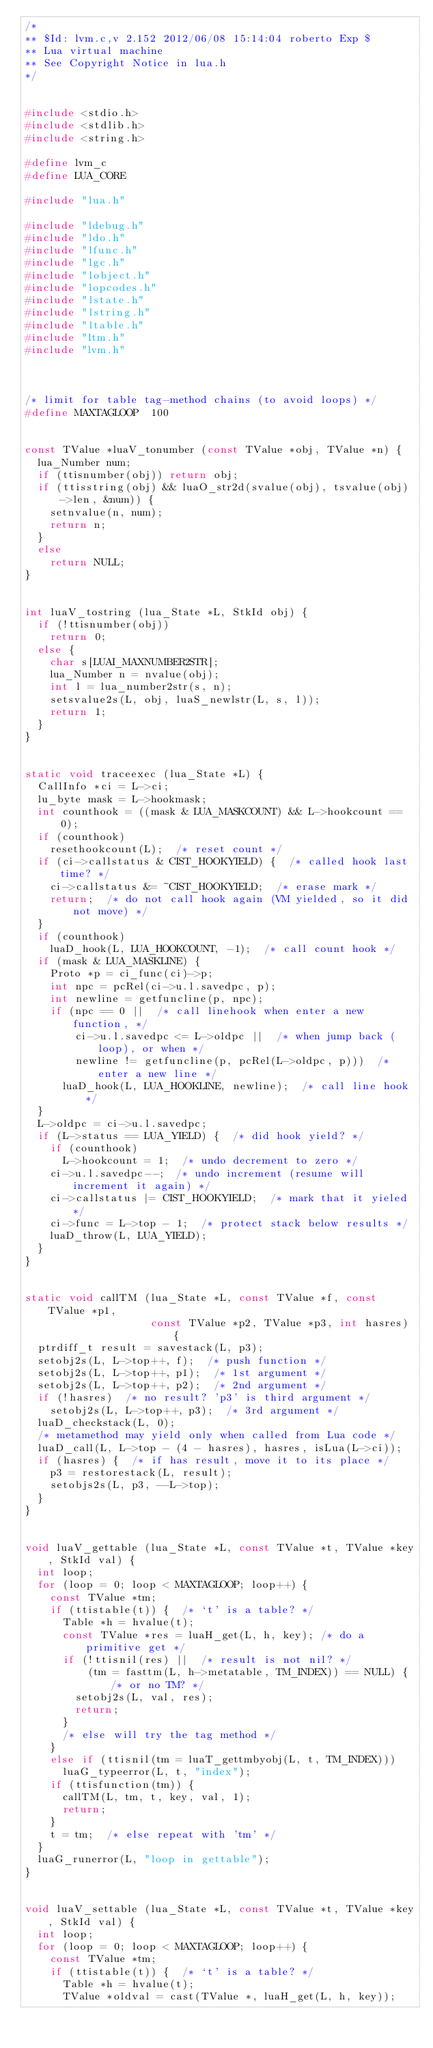Convert code to text. <code><loc_0><loc_0><loc_500><loc_500><_C_>/*
** $Id: lvm.c,v 2.152 2012/06/08 15:14:04 roberto Exp $
** Lua virtual machine
** See Copyright Notice in lua.h
*/


#include <stdio.h>
#include <stdlib.h>
#include <string.h>

#define lvm_c
#define LUA_CORE

#include "lua.h"

#include "ldebug.h"
#include "ldo.h"
#include "lfunc.h"
#include "lgc.h"
#include "lobject.h"
#include "lopcodes.h"
#include "lstate.h"
#include "lstring.h"
#include "ltable.h"
#include "ltm.h"
#include "lvm.h"



/* limit for table tag-method chains (to avoid loops) */
#define MAXTAGLOOP	100


const TValue *luaV_tonumber (const TValue *obj, TValue *n) {
  lua_Number num;
  if (ttisnumber(obj)) return obj;
  if (ttisstring(obj) && luaO_str2d(svalue(obj), tsvalue(obj)->len, &num)) {
    setnvalue(n, num);
    return n;
  }
  else
    return NULL;
}


int luaV_tostring (lua_State *L, StkId obj) {
  if (!ttisnumber(obj))
    return 0;
  else {
    char s[LUAI_MAXNUMBER2STR];
    lua_Number n = nvalue(obj);
    int l = lua_number2str(s, n);
    setsvalue2s(L, obj, luaS_newlstr(L, s, l));
    return 1;
  }
}


static void traceexec (lua_State *L) {
  CallInfo *ci = L->ci;
  lu_byte mask = L->hookmask;
  int counthook = ((mask & LUA_MASKCOUNT) && L->hookcount == 0);
  if (counthook)
    resethookcount(L);  /* reset count */
  if (ci->callstatus & CIST_HOOKYIELD) {  /* called hook last time? */
    ci->callstatus &= ~CIST_HOOKYIELD;  /* erase mark */
    return;  /* do not call hook again (VM yielded, so it did not move) */
  }
  if (counthook)
    luaD_hook(L, LUA_HOOKCOUNT, -1);  /* call count hook */
  if (mask & LUA_MASKLINE) {
    Proto *p = ci_func(ci)->p;
    int npc = pcRel(ci->u.l.savedpc, p);
    int newline = getfuncline(p, npc);
    if (npc == 0 ||  /* call linehook when enter a new function, */
        ci->u.l.savedpc <= L->oldpc ||  /* when jump back (loop), or when */
        newline != getfuncline(p, pcRel(L->oldpc, p)))  /* enter a new line */
      luaD_hook(L, LUA_HOOKLINE, newline);  /* call line hook */
  }
  L->oldpc = ci->u.l.savedpc;
  if (L->status == LUA_YIELD) {  /* did hook yield? */
    if (counthook)
      L->hookcount = 1;  /* undo decrement to zero */
    ci->u.l.savedpc--;  /* undo increment (resume will increment it again) */
    ci->callstatus |= CIST_HOOKYIELD;  /* mark that it yieled */
    ci->func = L->top - 1;  /* protect stack below results */
    luaD_throw(L, LUA_YIELD);
  }
}


static void callTM (lua_State *L, const TValue *f, const TValue *p1,
                    const TValue *p2, TValue *p3, int hasres) {
  ptrdiff_t result = savestack(L, p3);
  setobj2s(L, L->top++, f);  /* push function */
  setobj2s(L, L->top++, p1);  /* 1st argument */
  setobj2s(L, L->top++, p2);  /* 2nd argument */
  if (!hasres)  /* no result? 'p3' is third argument */
    setobj2s(L, L->top++, p3);  /* 3rd argument */
  luaD_checkstack(L, 0);
  /* metamethod may yield only when called from Lua code */
  luaD_call(L, L->top - (4 - hasres), hasres, isLua(L->ci));
  if (hasres) {  /* if has result, move it to its place */
    p3 = restorestack(L, result);
    setobjs2s(L, p3, --L->top);
  }
}


void luaV_gettable (lua_State *L, const TValue *t, TValue *key, StkId val) {
  int loop;
  for (loop = 0; loop < MAXTAGLOOP; loop++) {
    const TValue *tm;
    if (ttistable(t)) {  /* `t' is a table? */
      Table *h = hvalue(t);
      const TValue *res = luaH_get(L, h, key); /* do a primitive get */
      if (!ttisnil(res) ||  /* result is not nil? */
          (tm = fasttm(L, h->metatable, TM_INDEX)) == NULL) { /* or no TM? */
        setobj2s(L, val, res);
        return;
      }
      /* else will try the tag method */
    }
    else if (ttisnil(tm = luaT_gettmbyobj(L, t, TM_INDEX)))
      luaG_typeerror(L, t, "index");
    if (ttisfunction(tm)) {
      callTM(L, tm, t, key, val, 1);
      return;
    }
    t = tm;  /* else repeat with 'tm' */
  }
  luaG_runerror(L, "loop in gettable");
}


void luaV_settable (lua_State *L, const TValue *t, TValue *key, StkId val) {
  int loop;
  for (loop = 0; loop < MAXTAGLOOP; loop++) {
    const TValue *tm;
    if (ttistable(t)) {  /* `t' is a table? */
      Table *h = hvalue(t);
      TValue *oldval = cast(TValue *, luaH_get(L, h, key));</code> 